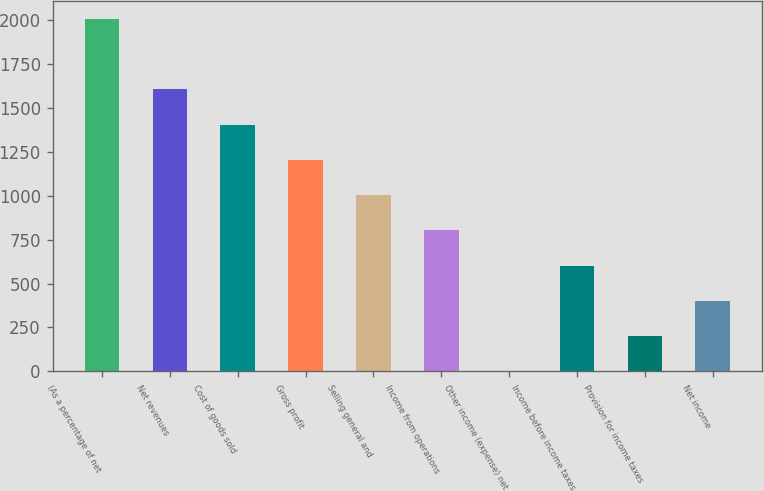Convert chart. <chart><loc_0><loc_0><loc_500><loc_500><bar_chart><fcel>(As a percentage of net<fcel>Net revenues<fcel>Cost of goods sold<fcel>Gross profit<fcel>Selling general and<fcel>Income from operations<fcel>Other income (expense) net<fcel>Income before income taxes<fcel>Provision for income taxes<fcel>Net income<nl><fcel>2005<fcel>1604.2<fcel>1403.8<fcel>1203.4<fcel>1003<fcel>802.6<fcel>1<fcel>602.2<fcel>201.4<fcel>401.8<nl></chart> 